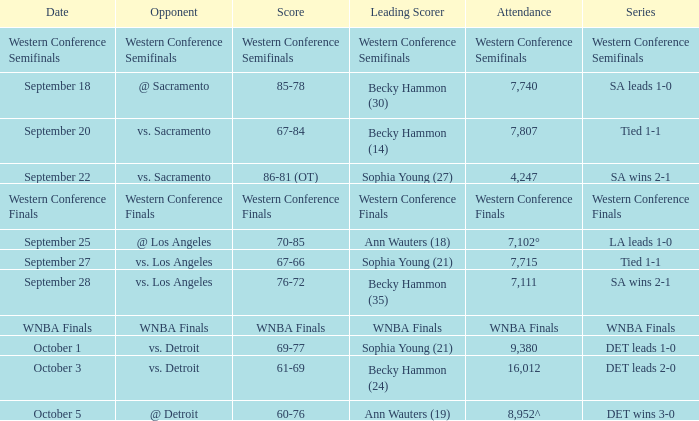What is the number of attendees for the western conference finals series? Western Conference Finals. 